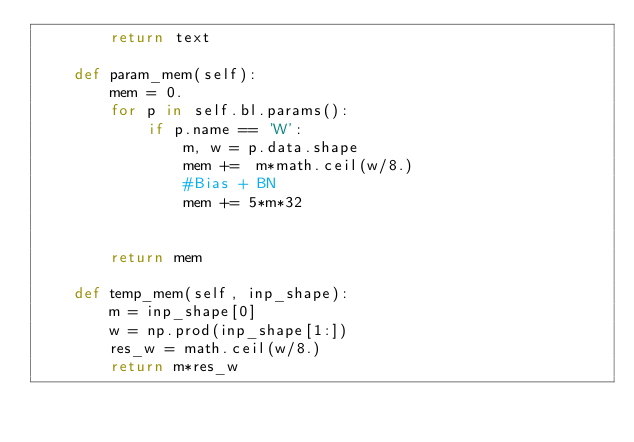Convert code to text. <code><loc_0><loc_0><loc_500><loc_500><_Python_>        return text

    def param_mem(self):
        mem = 0.
        for p in self.bl.params():
            if p.name == 'W':
                m, w = p.data.shape
                mem +=  m*math.ceil(w/8.)
                #Bias + BN
                mem += 5*m*32


        return mem

    def temp_mem(self, inp_shape):
        m = inp_shape[0]
        w = np.prod(inp_shape[1:])
        res_w = math.ceil(w/8.)
        return m*res_w
</code> 